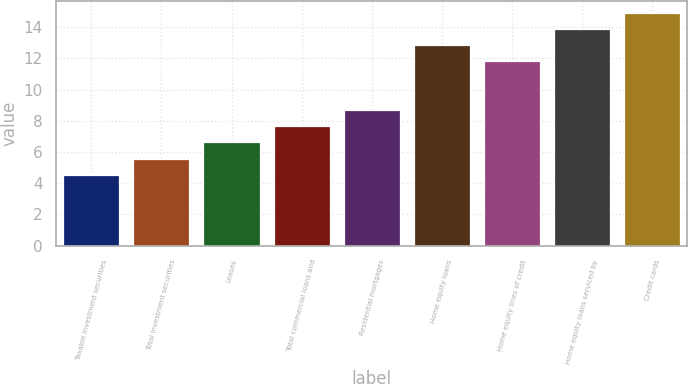Convert chart to OTSL. <chart><loc_0><loc_0><loc_500><loc_500><bar_chart><fcel>Taxable investment securities<fcel>Total investment securities<fcel>Leases<fcel>Total commercial loans and<fcel>Residential mortgages<fcel>Home equity loans<fcel>Home equity lines of credit<fcel>Home equity loans serviced by<fcel>Credit cards<nl><fcel>4.54<fcel>5.58<fcel>6.62<fcel>7.66<fcel>8.7<fcel>12.86<fcel>11.82<fcel>13.9<fcel>14.94<nl></chart> 